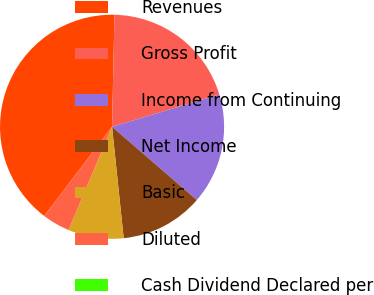Convert chart. <chart><loc_0><loc_0><loc_500><loc_500><pie_chart><fcel>Revenues<fcel>Gross Profit<fcel>Income from Continuing<fcel>Net Income<fcel>Basic<fcel>Diluted<fcel>Cash Dividend Declared per<nl><fcel>40.0%<fcel>20.0%<fcel>16.0%<fcel>12.0%<fcel>8.0%<fcel>4.0%<fcel>0.0%<nl></chart> 